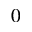Convert formula to latex. <formula><loc_0><loc_0><loc_500><loc_500>^ { 0 }</formula> 